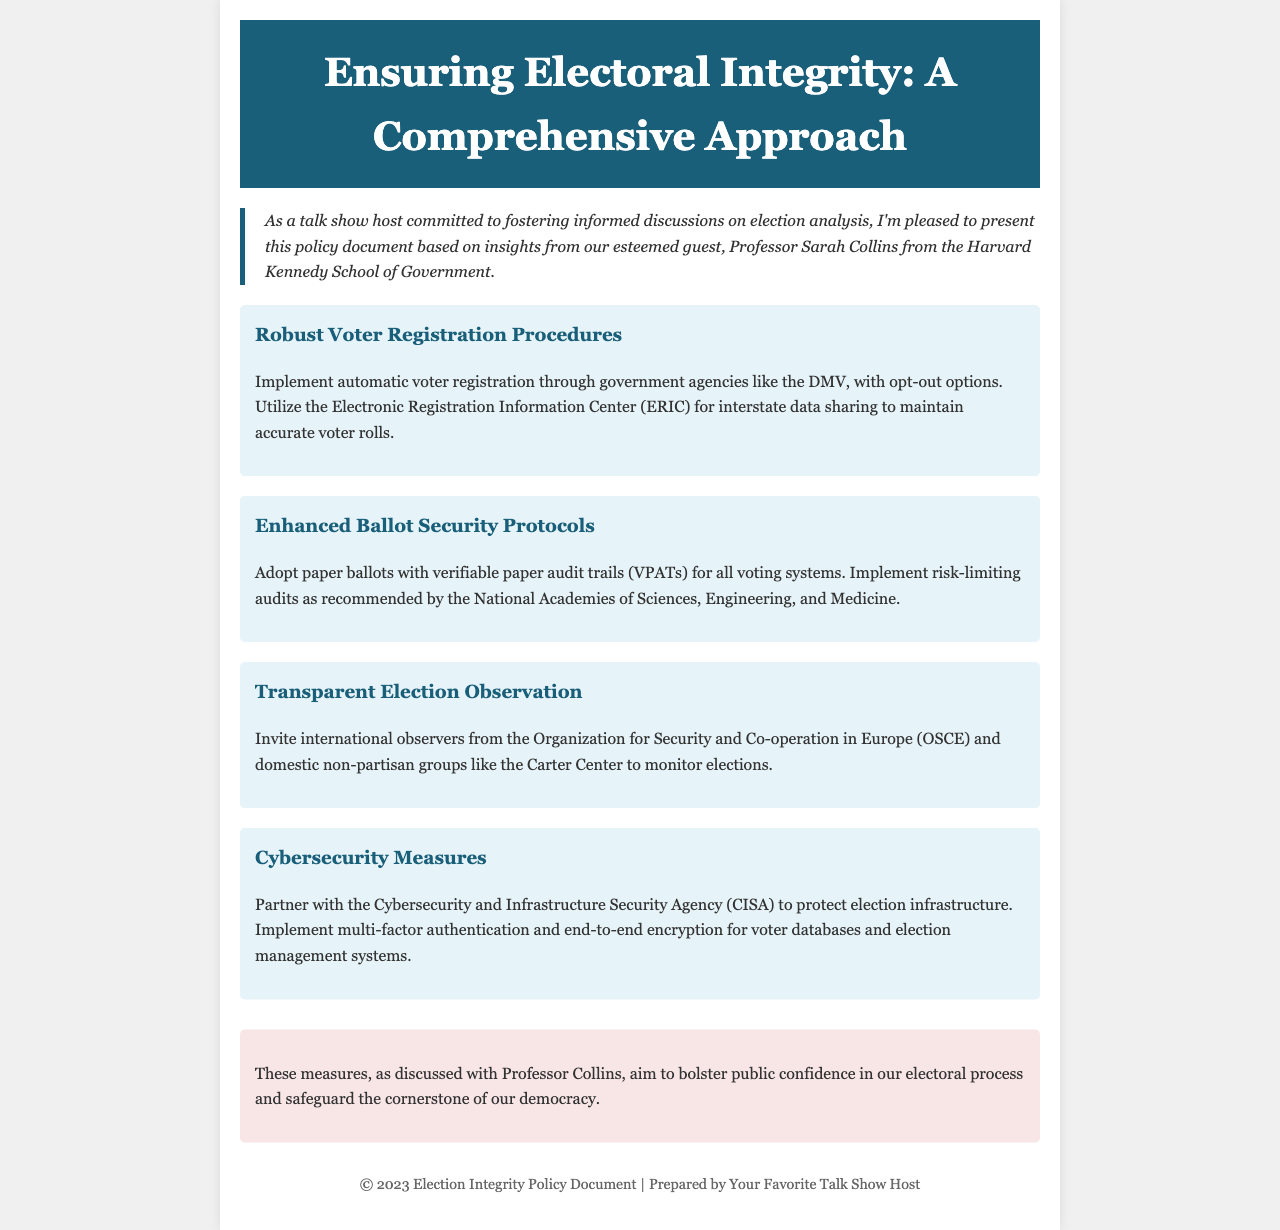What is the title of the document? The title of the document is presented prominently at the top of the page.
Answer: Ensuring Electoral Integrity: A Comprehensive Approach Who is the guest professor mentioned in the document? The document refers to a specific professor who contributed insights to the policy.
Answer: Professor Sarah Collins What organization is recommended for election monitoring? The document mentions a specific international organization for election observation.
Answer: Organization for Security and Co-operation in Europe (OSCE) How many measures are discussed in the document? The document lists several measures aimed at ensuring electoral integrity, which can be counted.
Answer: Four What type of ballots are advocated for adoption? The document specifies the type of ballots that should be used for voting.
Answer: Paper ballots Which agency should be partnered with for cybersecurity? The document identifies a specific agency to collaborate with for election infrastructure protection.
Answer: Cybersecurity and Infrastructure Security Agency (CISA) What type of audits does the document recommend? The document mentions a specific type of audit for election systems.
Answer: Risk-limiting audits What color is used in the header section? The document describes the color scheme for the header of the page.
Answer: Dark blue 